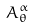<formula> <loc_0><loc_0><loc_500><loc_500>A _ { \theta } ^ { \alpha }</formula> 